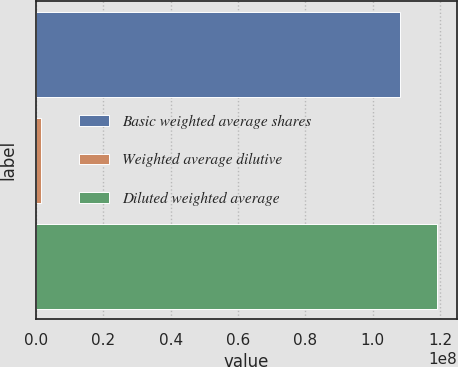<chart> <loc_0><loc_0><loc_500><loc_500><bar_chart><fcel>Basic weighted average shares<fcel>Weighted average dilutive<fcel>Diluted weighted average<nl><fcel>1.08278e+08<fcel>1.53728e+06<fcel>1.19106e+08<nl></chart> 